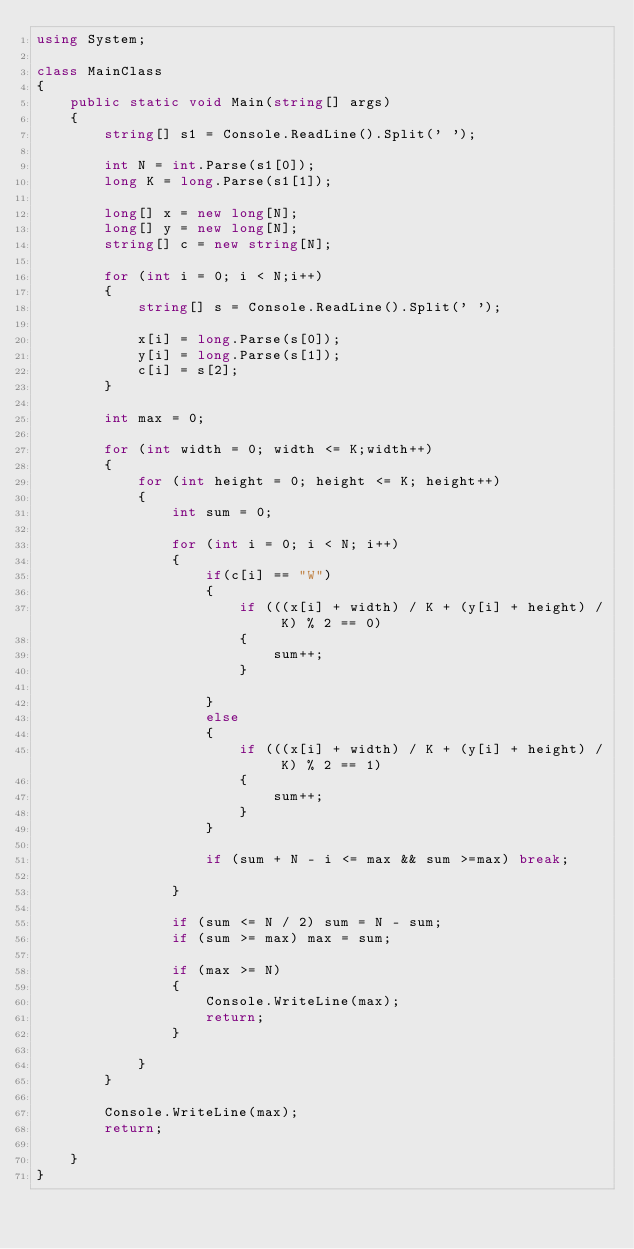<code> <loc_0><loc_0><loc_500><loc_500><_C#_>using System;

class MainClass
{
    public static void Main(string[] args)
    {
        string[] s1 = Console.ReadLine().Split(' ');

        int N = int.Parse(s1[0]);
        long K = long.Parse(s1[1]);
       
        long[] x = new long[N];
        long[] y = new long[N];
        string[] c = new string[N];

        for (int i = 0; i < N;i++)
        {
            string[] s = Console.ReadLine().Split(' ');

            x[i] = long.Parse(s[0]);
            y[i] = long.Parse(s[1]);
            c[i] = s[2];
        }

        int max = 0;

        for (int width = 0; width <= K;width++)
        {
            for (int height = 0; height <= K; height++)
            {
                int sum = 0;

                for (int i = 0; i < N; i++)
                {
                    if(c[i] == "W")
                    {
                        if (((x[i] + width) / K + (y[i] + height) / K) % 2 == 0)
                        {
                            sum++;
                        }

                    }
                    else
                    {
                        if (((x[i] + width) / K + (y[i] + height) / K) % 2 == 1)
                        {
                            sum++;
                        }
                    }

                    if (sum + N - i <= max && sum >=max) break;

                }

                if (sum <= N / 2) sum = N - sum;
                if (sum >= max) max = sum;

                if (max >= N)
                {
                    Console.WriteLine(max);
                    return;
                }

            } 
        }

        Console.WriteLine(max);
        return;

    }
}
</code> 